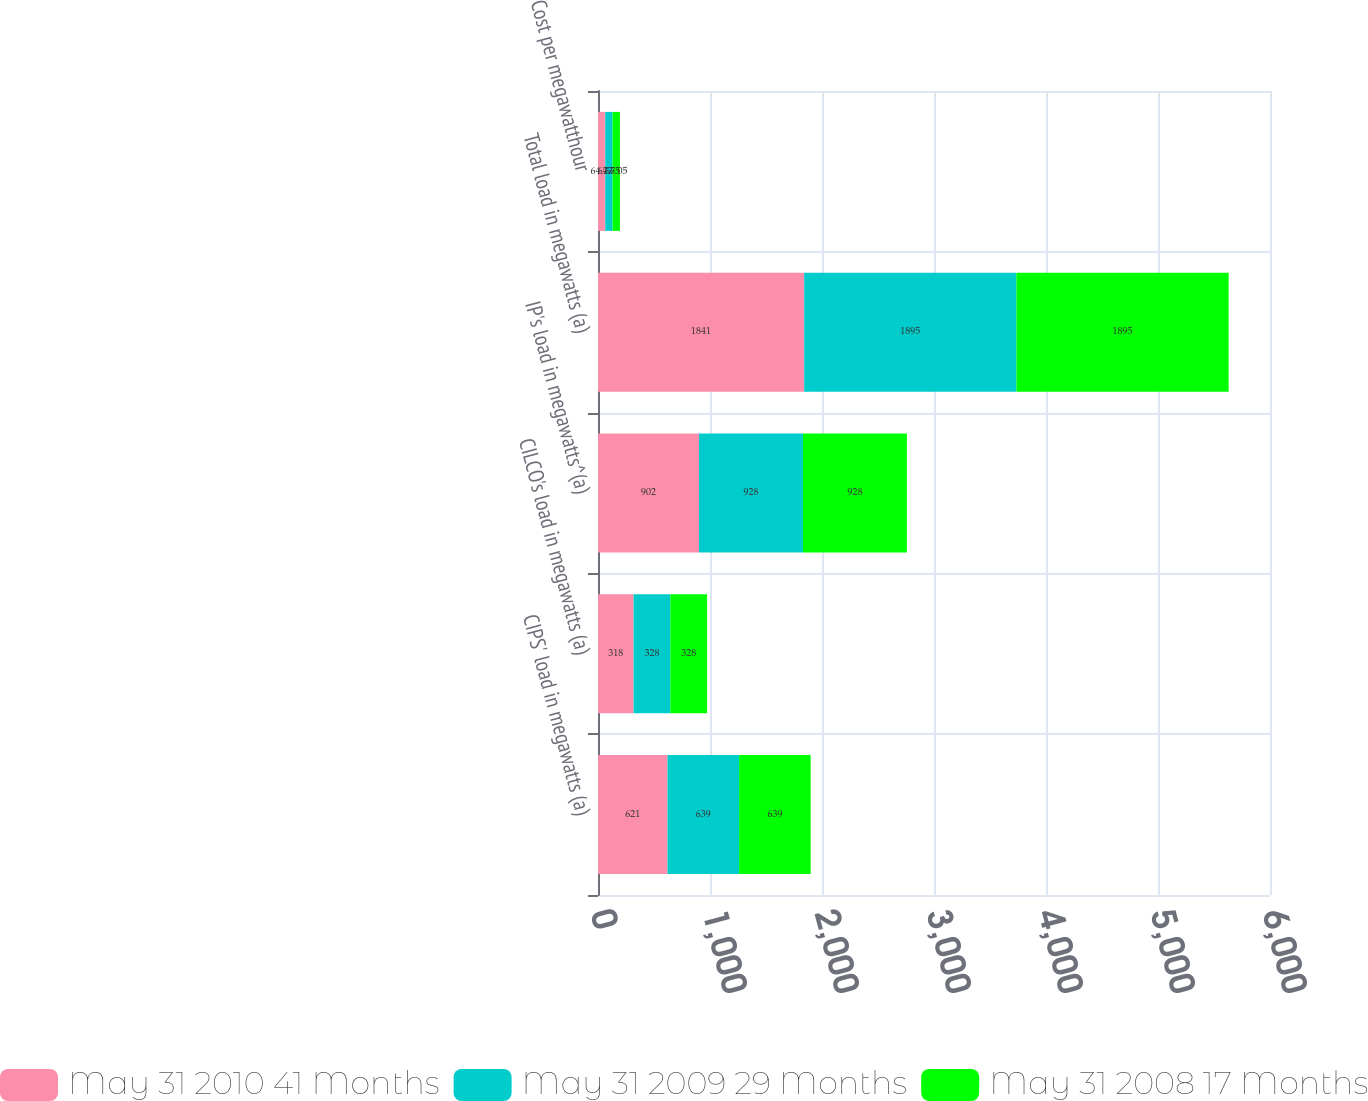<chart> <loc_0><loc_0><loc_500><loc_500><stacked_bar_chart><ecel><fcel>CIPS' load in megawatts (a)<fcel>CILCO's load in megawatts (a)<fcel>IP's load in megawatts^(a)<fcel>Total load in megawatts (a)<fcel>Cost per megawatthour<nl><fcel>May 31 2010 41 Months<fcel>621<fcel>318<fcel>902<fcel>1841<fcel>64.77<nl><fcel>May 31 2009 29 Months<fcel>639<fcel>328<fcel>928<fcel>1895<fcel>64.75<nl><fcel>May 31 2008 17 Months<fcel>639<fcel>328<fcel>928<fcel>1895<fcel>66.05<nl></chart> 